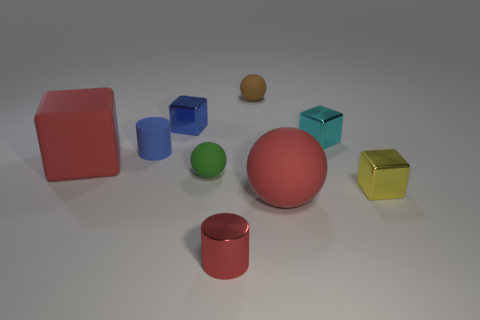Do the small brown ball and the yellow cube have the same material?
Give a very brief answer. No. There is a small cyan shiny object; what number of small matte spheres are behind it?
Offer a terse response. 1. There is a red matte object that is the same shape as the brown object; what is its size?
Your answer should be very brief. Large. How many green objects are either tiny metal cylinders or spheres?
Provide a succinct answer. 1. There is a tiny green matte thing that is behind the tiny yellow metallic thing; how many metallic things are in front of it?
Provide a short and direct response. 2. How many other objects are the same shape as the small brown object?
Offer a very short reply. 2. What material is the small cylinder that is the same color as the big matte sphere?
Your answer should be compact. Metal. What number of tiny rubber spheres have the same color as the large rubber ball?
Keep it short and to the point. 0. What color is the tiny cylinder that is made of the same material as the large red block?
Ensure brevity in your answer.  Blue. Is there a gray ball of the same size as the green rubber thing?
Provide a succinct answer. No. 